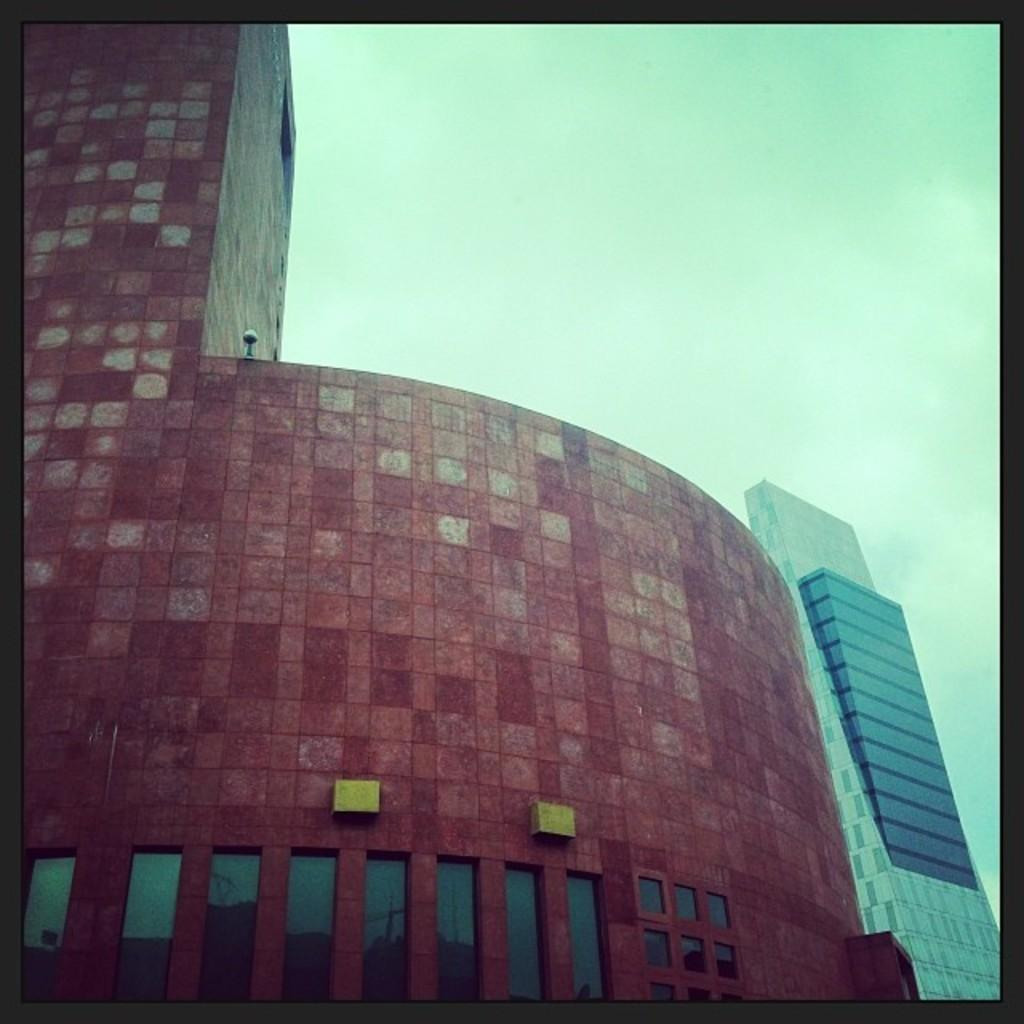What is the main subject in the center of the image? There are buildings in the center of the image. What can be seen at the top of the image? The sky is visible at the top of the image. What type of board is being used to surf on the island in the image? There is no board or island present in the image; it features buildings and the sky. 